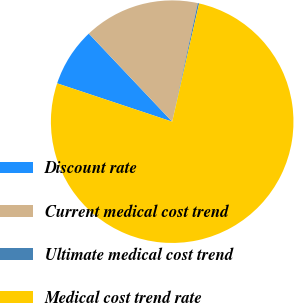Convert chart. <chart><loc_0><loc_0><loc_500><loc_500><pie_chart><fcel>Discount rate<fcel>Current medical cost trend<fcel>Ultimate medical cost trend<fcel>Medical cost trend rate<nl><fcel>7.82%<fcel>15.45%<fcel>0.18%<fcel>76.55%<nl></chart> 